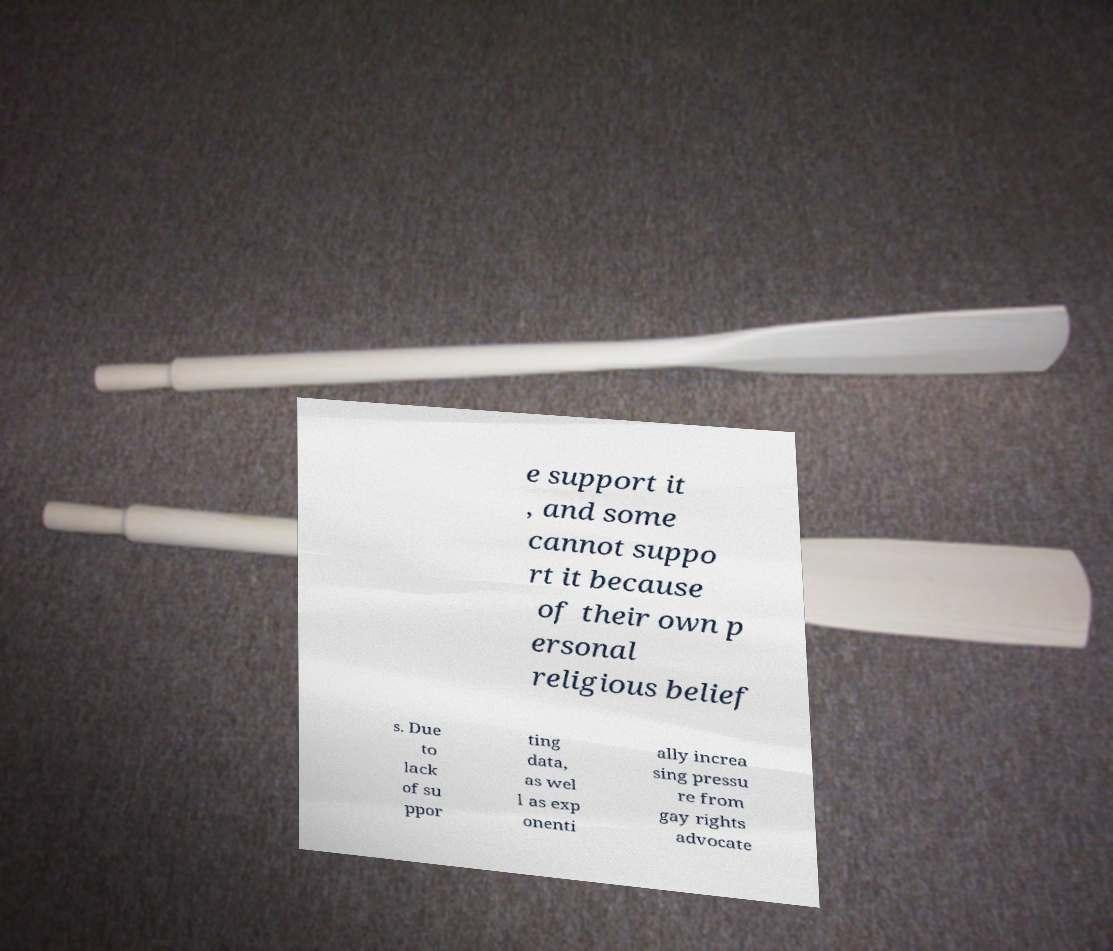Please identify and transcribe the text found in this image. e support it , and some cannot suppo rt it because of their own p ersonal religious belief s. Due to lack of su ppor ting data, as wel l as exp onenti ally increa sing pressu re from gay rights advocate 